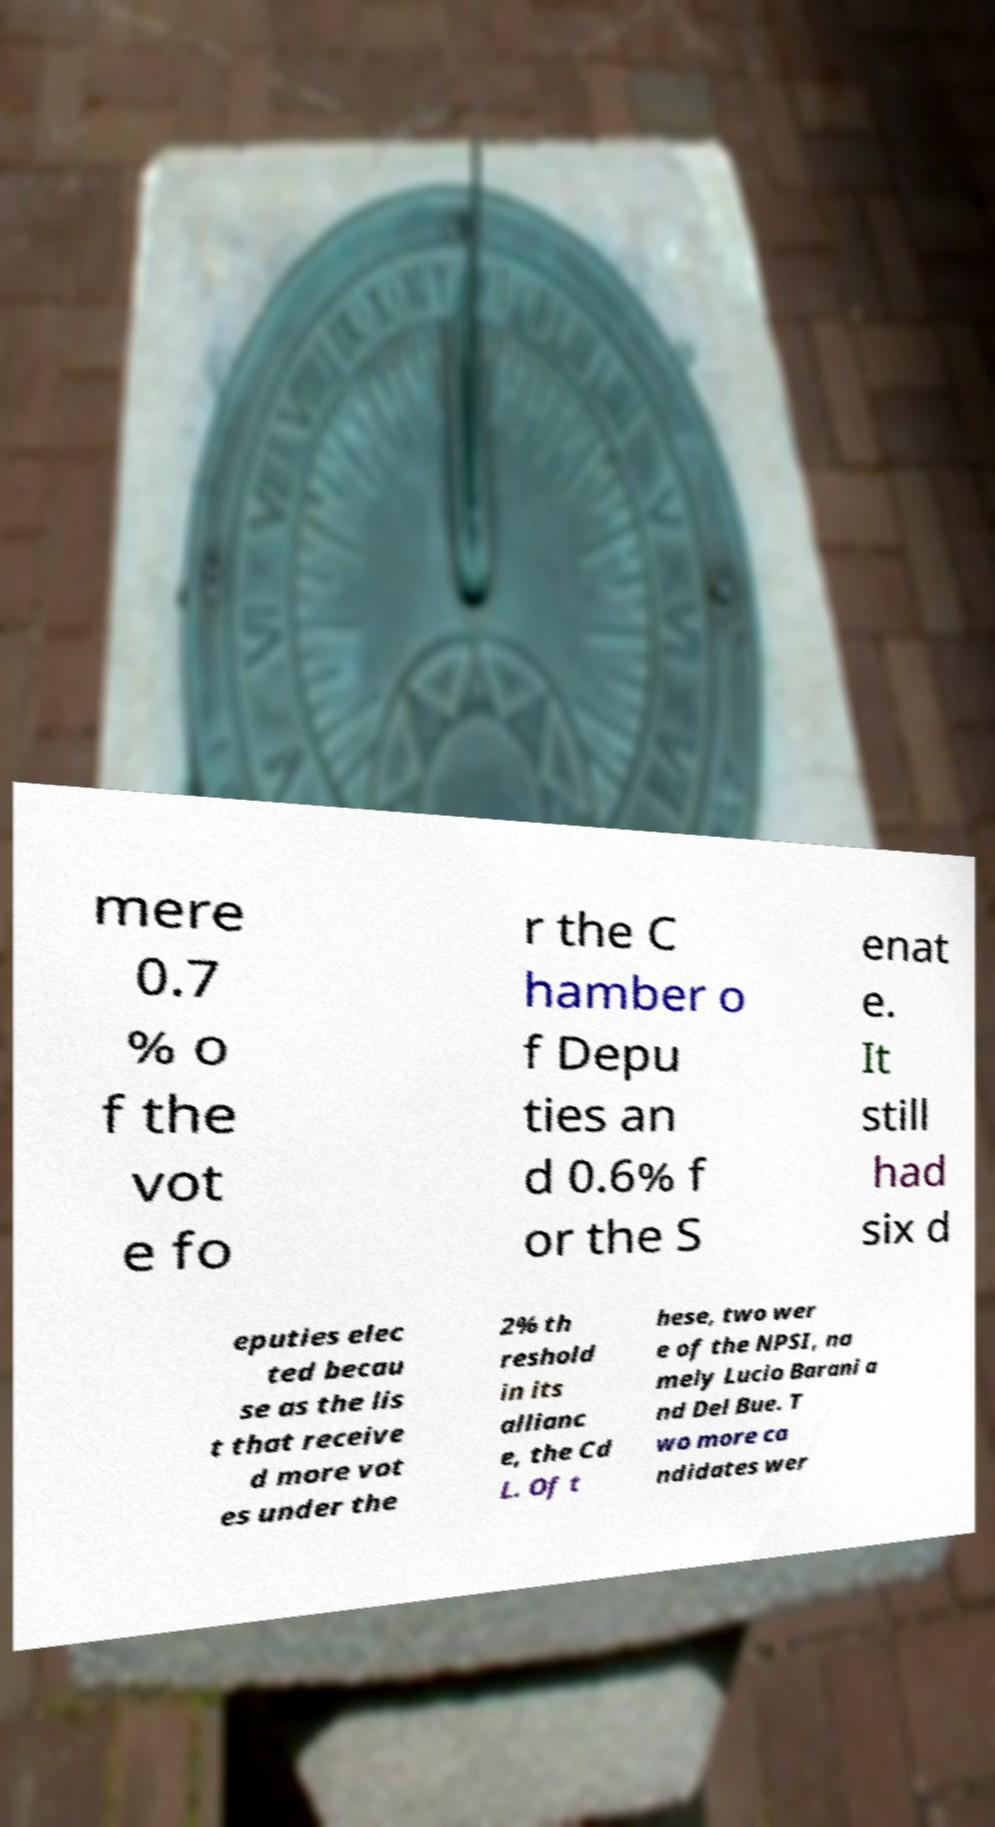Please identify and transcribe the text found in this image. mere 0.7 % o f the vot e fo r the C hamber o f Depu ties an d 0.6% f or the S enat e. It still had six d eputies elec ted becau se as the lis t that receive d more vot es under the 2% th reshold in its allianc e, the Cd L. Of t hese, two wer e of the NPSI, na mely Lucio Barani a nd Del Bue. T wo more ca ndidates wer 